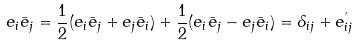Convert formula to latex. <formula><loc_0><loc_0><loc_500><loc_500>e _ { i } \bar { e } _ { j } = \frac { 1 } { 2 } ( e _ { i } \bar { e } _ { j } + e _ { j } \bar { e } _ { i } ) + \frac { 1 } { 2 } ( e _ { i } \bar { e } _ { j } - e _ { j } \bar { e } _ { i } ) = \delta _ { i j } + e _ { i j } ^ { ^ { \prime } }</formula> 